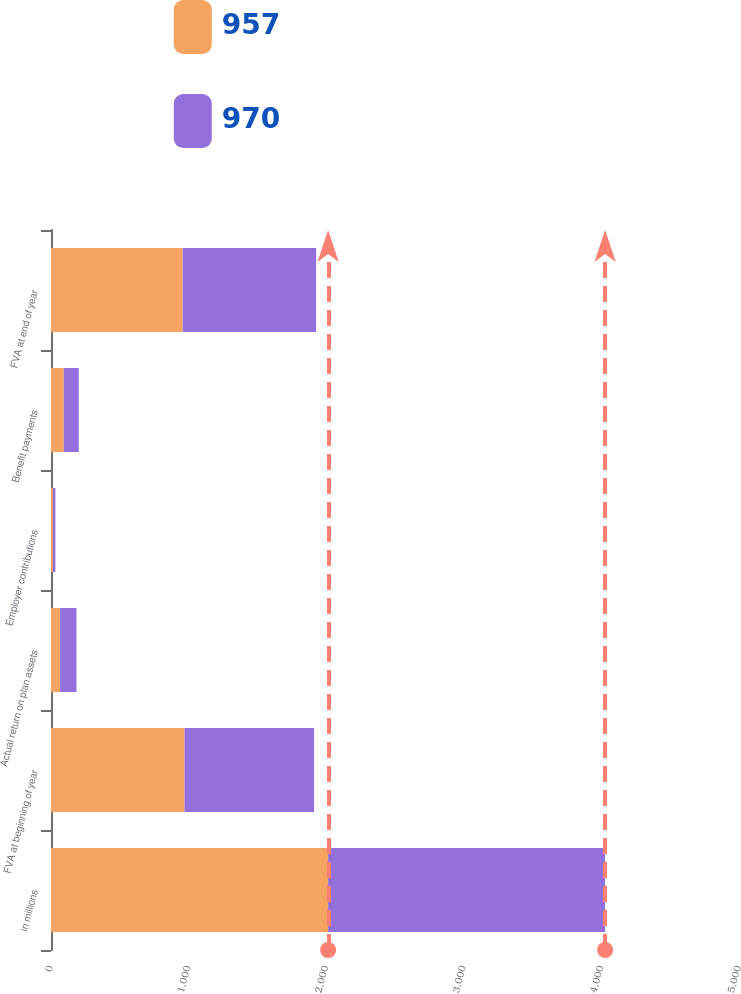Convert chart to OTSL. <chart><loc_0><loc_0><loc_500><loc_500><stacked_bar_chart><ecel><fcel>in millions<fcel>FVA at beginning of year<fcel>Actual return on plan assets<fcel>Employer contributions<fcel>Benefit payments<fcel>FVA at end of year<nl><fcel>957<fcel>2014<fcel>970<fcel>66<fcel>14<fcel>93<fcel>957<nl><fcel>970<fcel>2013<fcel>942<fcel>119<fcel>18<fcel>109<fcel>970<nl></chart> 